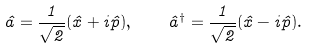Convert formula to latex. <formula><loc_0><loc_0><loc_500><loc_500>\hat { a } = \frac { 1 } { \sqrt { 2 } } ( \hat { x } + i \hat { p } ) , \quad \hat { a } ^ { \dagger } = \frac { 1 } { \sqrt { 2 } } ( \hat { x } - i \hat { p } ) .</formula> 